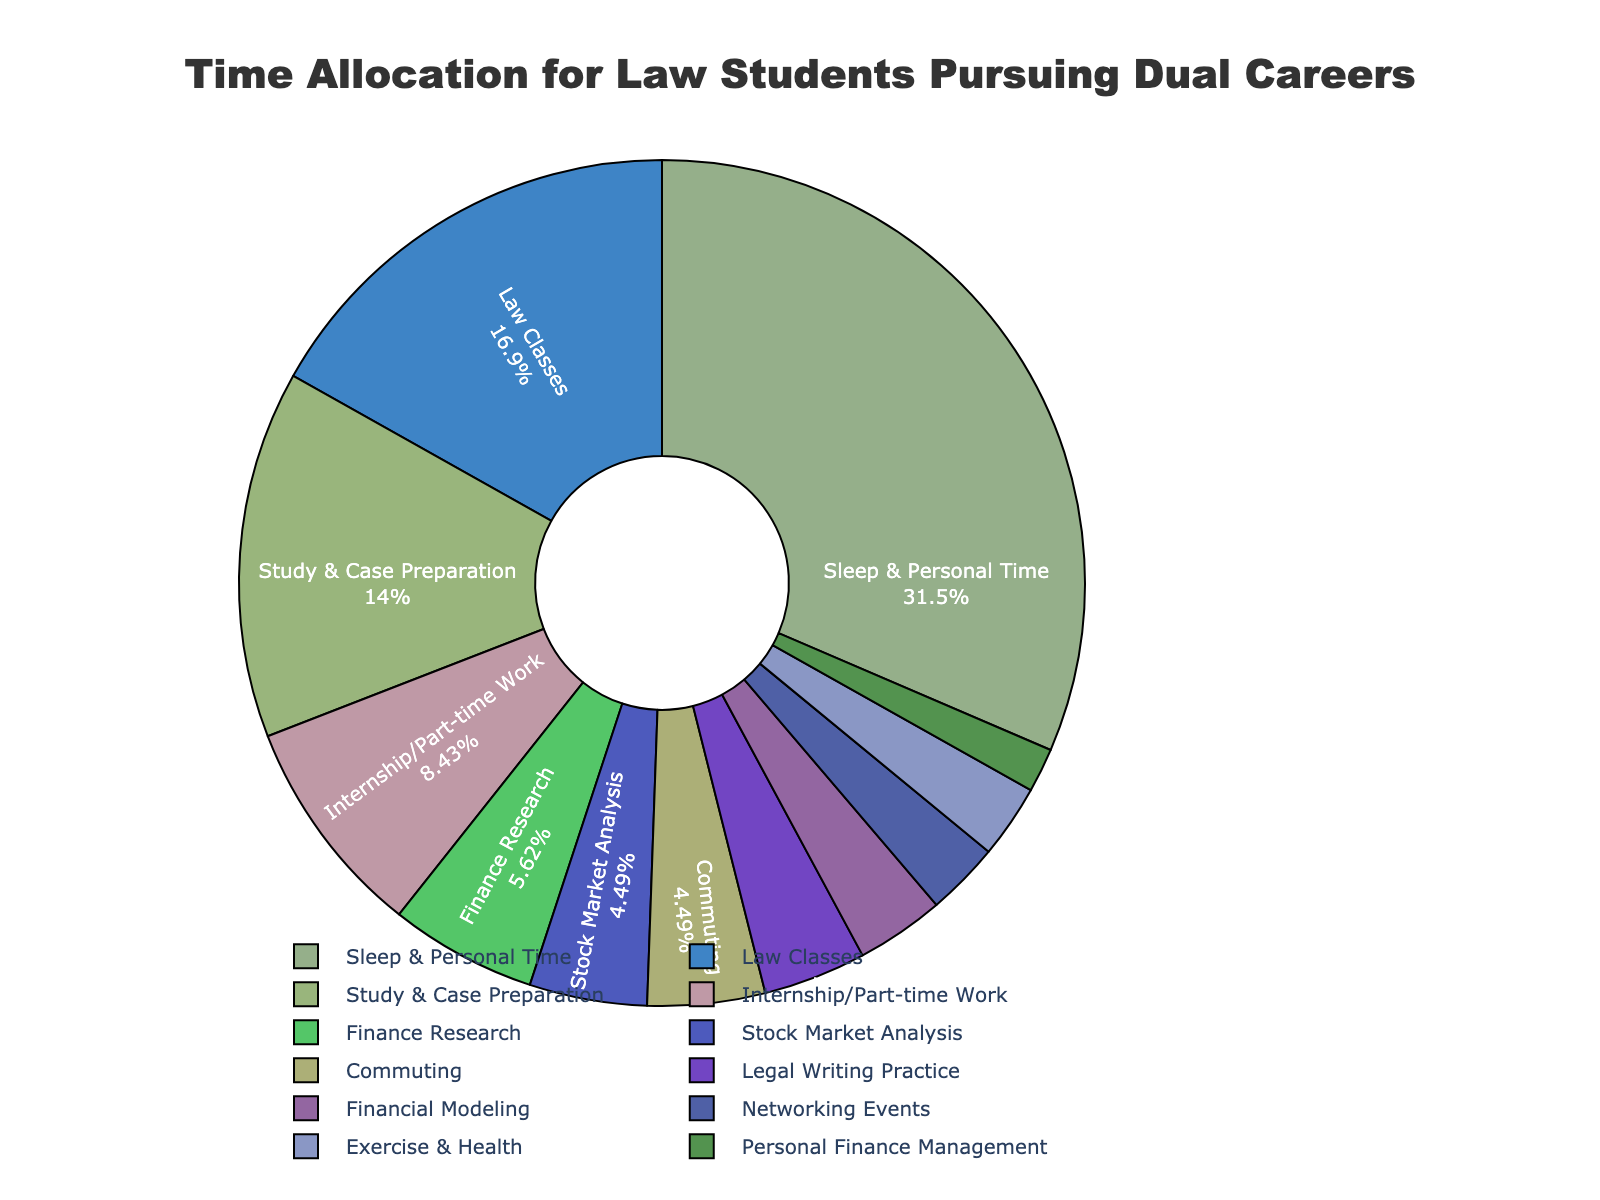What's the largest time allocation category for law students pursuing dual careers? The figure shows a pie chart with different categories and their respective time allocations. By observing the size of the segments, the largest category can be identified as "Sleep & Personal Time" with 56 hours per week.
Answer: Sleep & Personal Time Which category takes up more time: Finance Research or Legal Writing Practice? The pie chart segments for Finance Research and Legal Writing Practice can be compared by their sizes. Finance Research is allocated 10 hours per week, whereas Legal Writing Practice is allocated 7 hours per week.
Answer: Finance Research What is the combined time spent on Finance Research and Stock Market Analysis? To find the combined time, add the hours per week for Finance Research (10 hours) and Stock Market Analysis (8 hours). 10 + 8 = 18 hours.
Answer: 18 hours Which category has the smallest time allocation? By comparing the sizes of the pie chart segments, the smallest category can be identified. “Personal Finance Management” has the smallest allocation with 3 hours per week.
Answer: Personal Finance Management Is more time spent on Internship/Part-time Work or Networking Events? By examining the segments for Internship/Part-time Work and Networking Events, Internship/Part-time Work is allocated 15 hours per week, whereas Networking Events is allocated 5 hours per week.
Answer: Internship/Part-time Work How does the time spent on Exercise & Health compare with Commuting? By comparing the pie chart segments, Exercise & Health is allocated 5 hours per week, while Commuting is allocated 8 hours per week. Commuting has more hours.
Answer: Commuting What percentage of the total time is devoted to Law Classes and Study & Case Preparation combined? The total time is the sum of all hours, which adds up to 178 hours. The time for Law Classes and Study & Case Preparation combined is 30 + 25 = 55 hours. To find the percentage, calculate (55/178) * 100 ≈ 30.9%.
Answer: 30.9% How much more time is allocated to Internship/Part-time Work than to Financial Modeling? Internship/Part-time Work has 15 hours per week, and Financial Modeling has 6 hours per week. The difference is 15 - 6 = 9 hours.
Answer: 9 hours Which activity has more allocated hours: Networking Events or Exercise & Health? By observing the sizes of the segments for Networking Events and Exercise & Health, both are allocated 5 hours per week. Thus, they are equal.
Answer: Equal 